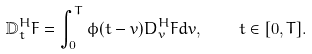Convert formula to latex. <formula><loc_0><loc_0><loc_500><loc_500>\mathbb { D } _ { t } ^ { H } F = \int _ { 0 } ^ { T } \phi ( t - v ) D _ { v } ^ { H } F d v , \quad t \in [ 0 , T ] .</formula> 